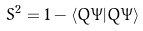<formula> <loc_0><loc_0><loc_500><loc_500>S ^ { 2 } = 1 - \langle Q \Psi | Q \Psi \rangle</formula> 